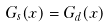Convert formula to latex. <formula><loc_0><loc_0><loc_500><loc_500>G _ { s } ( x ) = G _ { d } ( x )</formula> 